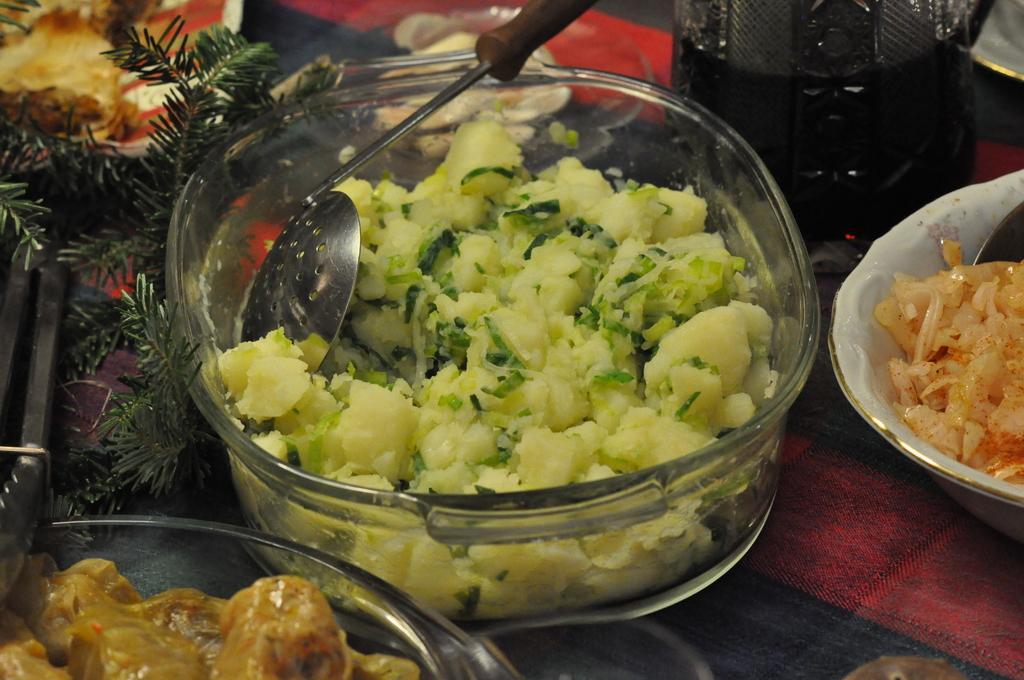Please provide a concise description of this image. In this picture we can see bowls, food items, spoon, some objects and these all are placed on a platform. 